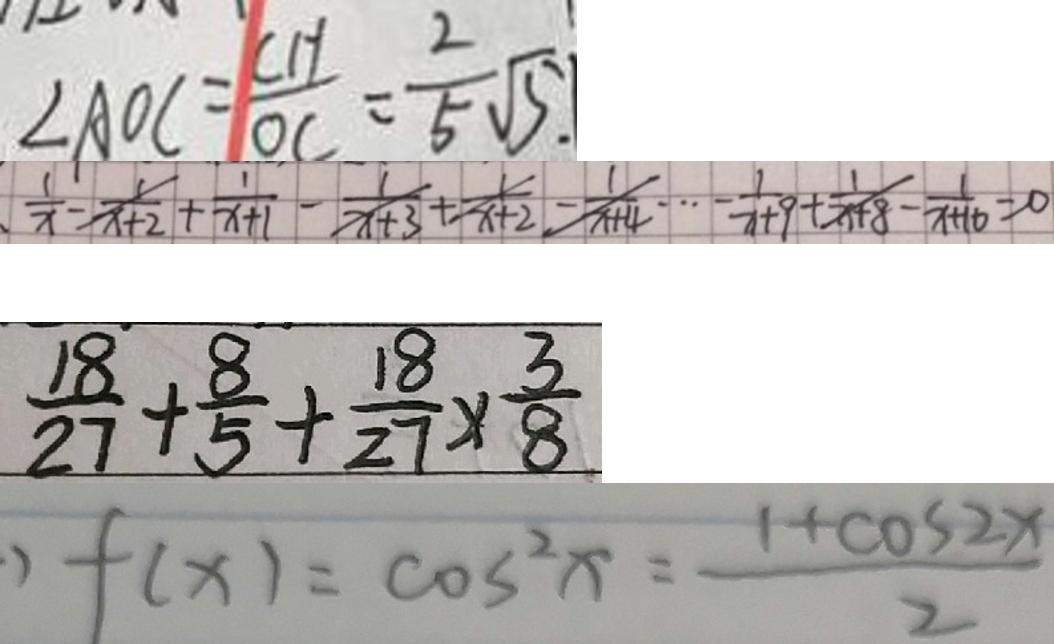Convert formula to latex. <formula><loc_0><loc_0><loc_500><loc_500>\angle A O C = \frac { C H } { O C } = \frac { 2 } { 5 } \sqrt { 5 . } 
 \frac { 1 } { x } - \frac { 1 } { x + 2 } + \frac { 1 } { x + 1 } - \frac { 1 } { x + 3 } + \frac { 1 } { x + 2 } - \frac { 1 } { x + 4 } \dot { s } - \frac { 1 } { x + 9 } + \frac { 1 } { x + 8 } - \frac { 1 } { x + 1 0 } = 0 
 \frac { 1 8 } { 2 7 } + \frac { 8 } { 5 } + \frac { 1 8 } { 2 7 } \times \frac { 3 } { 8 } 
 ) f ( x ) = \cos ^ { 2 } x = \frac { 1 + \cos 2 x } { 2 }</formula> 